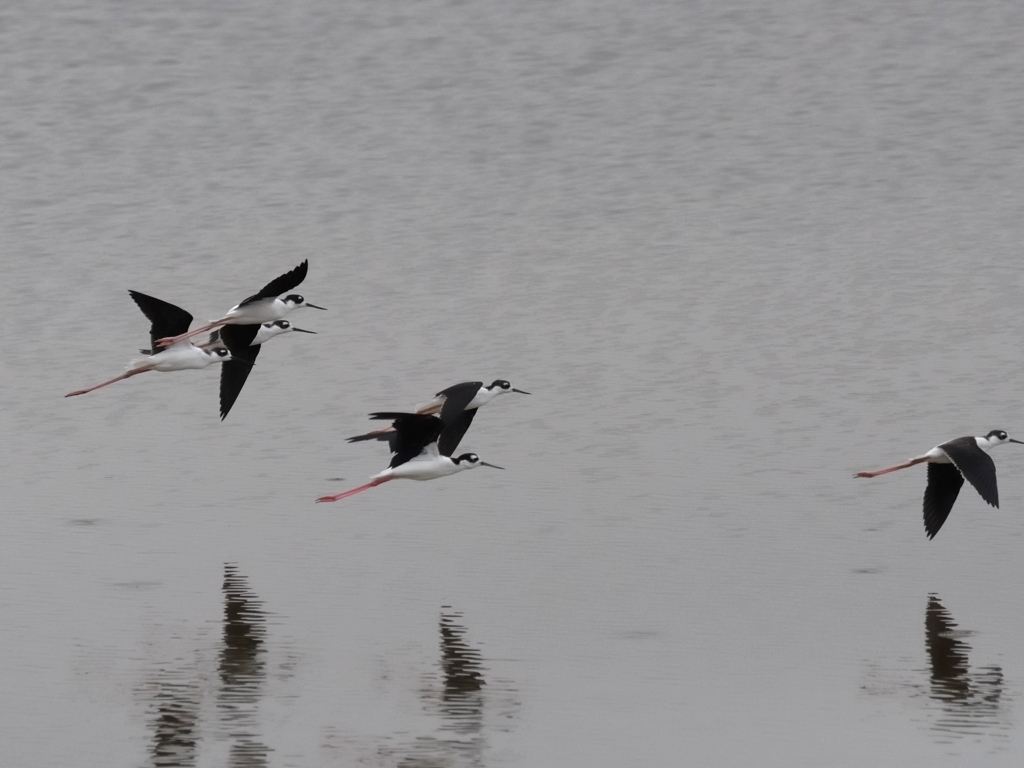What species of birds are these, and can you tell me about their habitat? These birds are Black-winged Stilts, characterized by their long legs, black and white plumage, and distinct flight pattern. They typically inhabit shallow wetlands and are known for their wading behavior in search of invertebrates to feed on. 